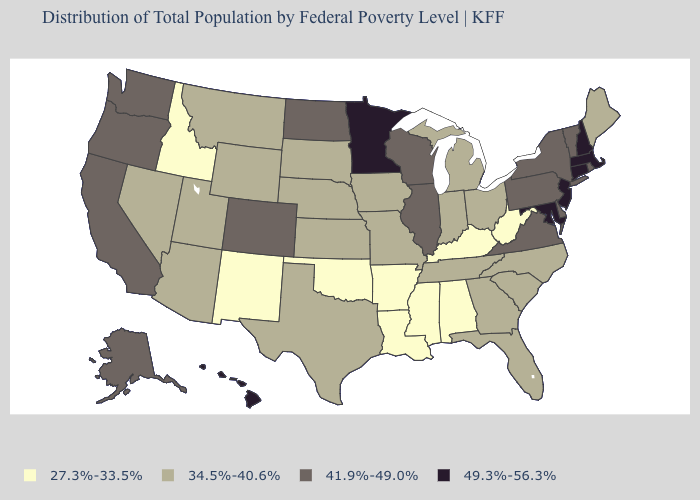Does Texas have the lowest value in the South?
Short answer required. No. Name the states that have a value in the range 27.3%-33.5%?
Answer briefly. Alabama, Arkansas, Idaho, Kentucky, Louisiana, Mississippi, New Mexico, Oklahoma, West Virginia. What is the value of Michigan?
Write a very short answer. 34.5%-40.6%. Name the states that have a value in the range 27.3%-33.5%?
Give a very brief answer. Alabama, Arkansas, Idaho, Kentucky, Louisiana, Mississippi, New Mexico, Oklahoma, West Virginia. What is the value of Alabama?
Answer briefly. 27.3%-33.5%. Name the states that have a value in the range 27.3%-33.5%?
Quick response, please. Alabama, Arkansas, Idaho, Kentucky, Louisiana, Mississippi, New Mexico, Oklahoma, West Virginia. How many symbols are there in the legend?
Give a very brief answer. 4. Name the states that have a value in the range 49.3%-56.3%?
Write a very short answer. Connecticut, Hawaii, Maryland, Massachusetts, Minnesota, New Hampshire, New Jersey. Does Minnesota have the highest value in the MidWest?
Write a very short answer. Yes. Does the first symbol in the legend represent the smallest category?
Short answer required. Yes. What is the value of North Dakota?
Give a very brief answer. 41.9%-49.0%. What is the value of Mississippi?
Short answer required. 27.3%-33.5%. Which states have the highest value in the USA?
Keep it brief. Connecticut, Hawaii, Maryland, Massachusetts, Minnesota, New Hampshire, New Jersey. Which states have the highest value in the USA?
Quick response, please. Connecticut, Hawaii, Maryland, Massachusetts, Minnesota, New Hampshire, New Jersey. 